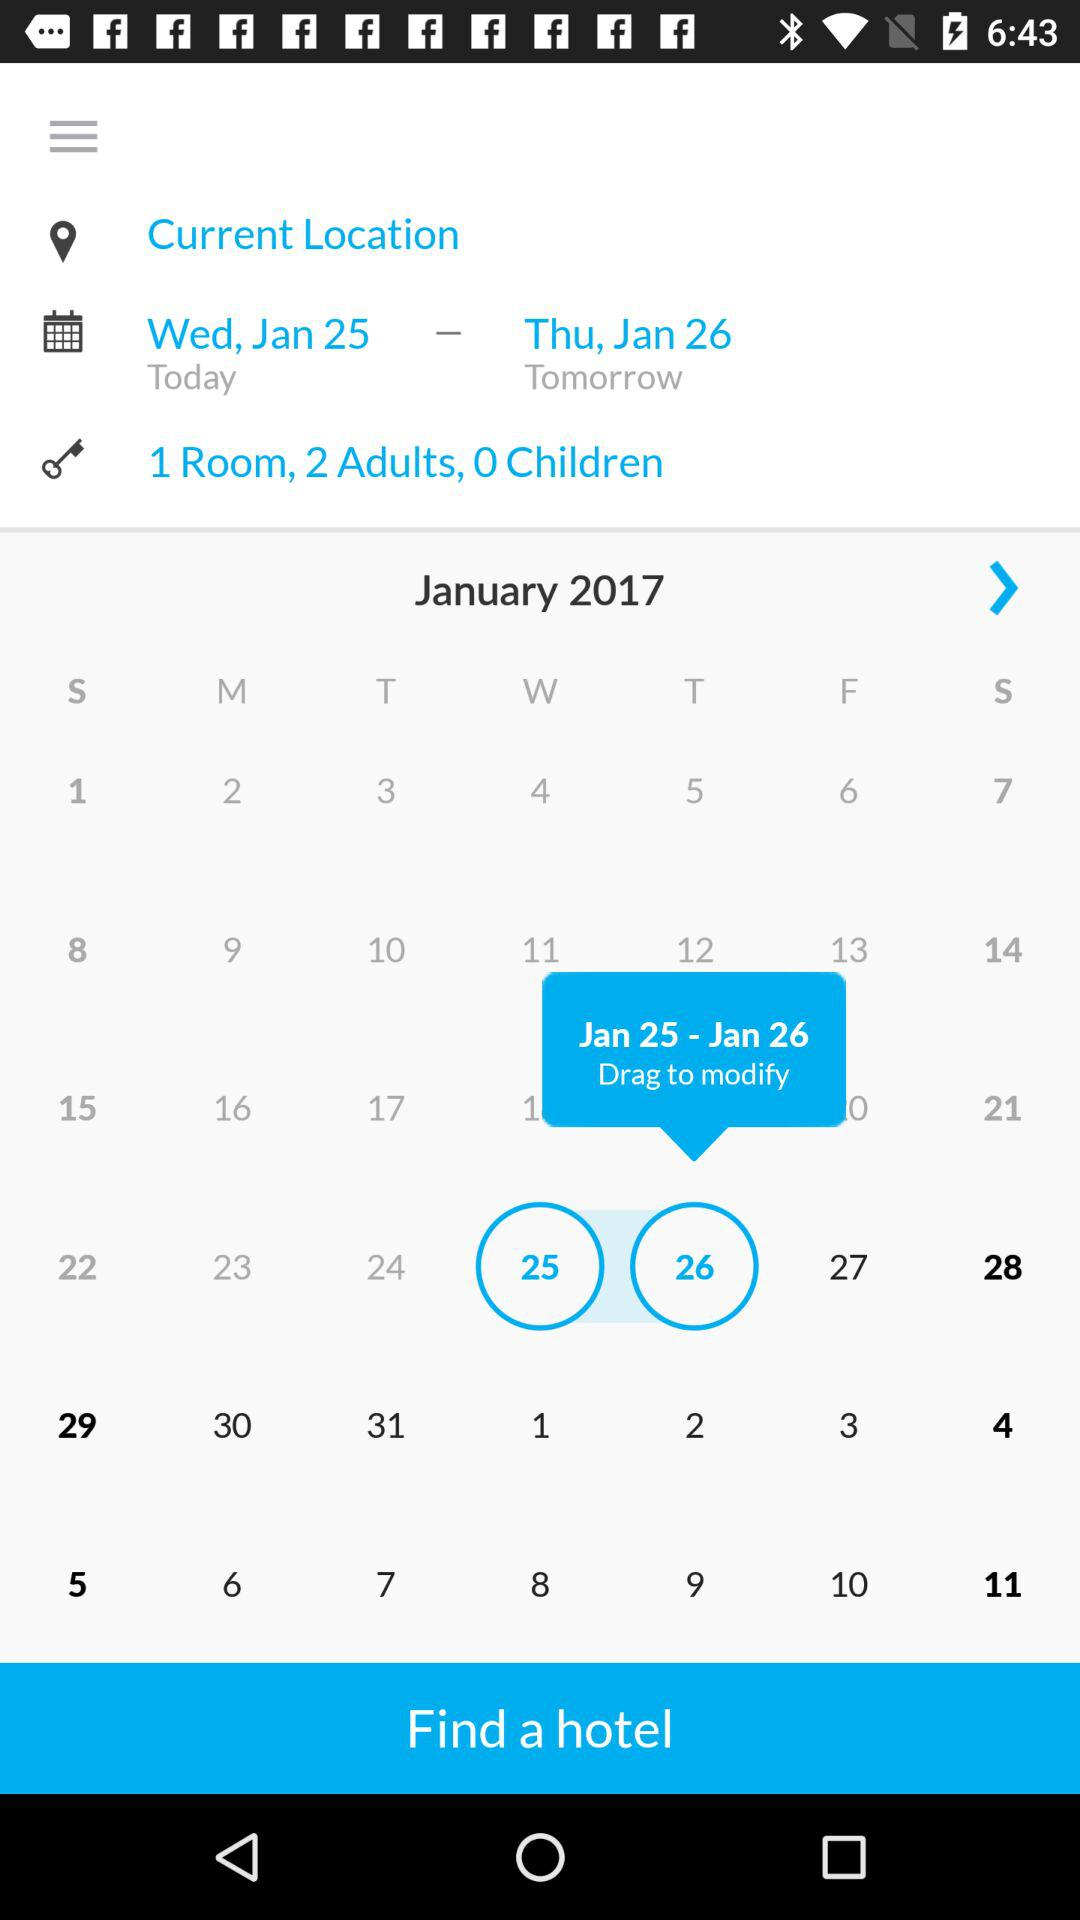What day is it on January 25? The day is Wednesday. 